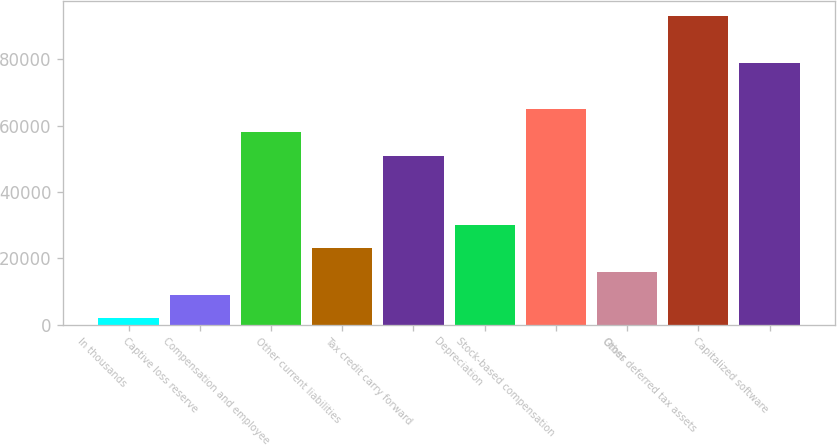Convert chart. <chart><loc_0><loc_0><loc_500><loc_500><bar_chart><fcel>In thousands<fcel>Captive loss reserve<fcel>Compensation and employee<fcel>Other current liabilities<fcel>Tax credit carry forward<fcel>Depreciation<fcel>Stock-based compensation<fcel>Other<fcel>Gross deferred tax assets<fcel>Capitalized software<nl><fcel>2008<fcel>9006.6<fcel>57996.8<fcel>23003.8<fcel>50998.2<fcel>30002.4<fcel>64995.4<fcel>16005.2<fcel>92989.8<fcel>78992.6<nl></chart> 